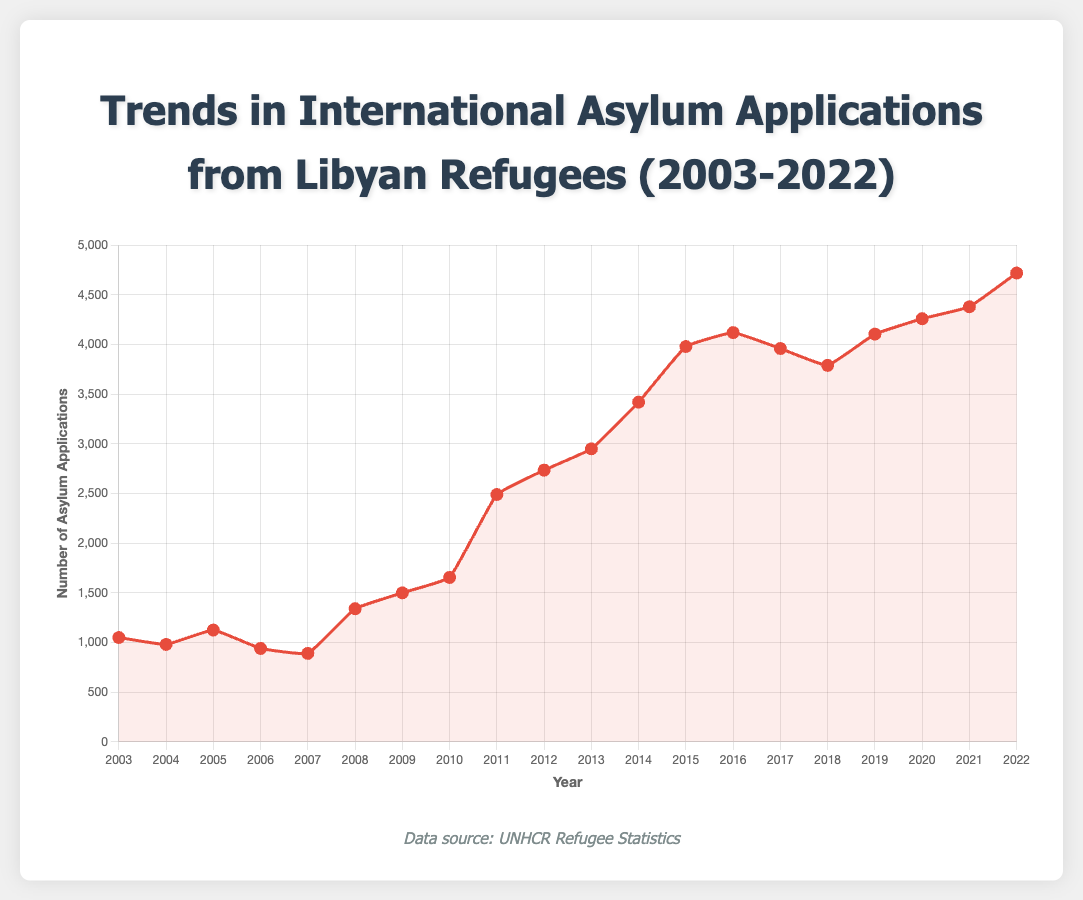What is the overall trend in the number of asylum applications from Libyan refugees over the past 20 years? Looking at the line plot, the number of asylum applications generally increased over the 20-year period from 2003 to 2022. There was a noticeable rise starting around 2008, with more significant increases during and after 2011, and a steady upward trend continuing through 2022.
Answer: An increasing trend Which year had the highest number of asylum applications? By examining the peak of the line plot, it is clear that 2022 had the highest number of asylum applications with a value of 4720.
Answer: 2022 How did the number of asylum applications change from 2010 to 2011? Comparing the points on the line plot representing 2010 and 2011, the number of asylum applications increased from 1655 in 2010 to 2490 in 2011. The difference is 2490 - 1655 = 835.
Answer: Increased by 835 What is the average number of asylum applications per year from 2003 to 2022? Calculating the average involves summing the total number of asylum applications over the years and dividing by the number of years. Summing up the applications: 1050 + 980 + 1125 + 940 + 890 + 1340 + 1500 + 1655 + 2490 + 2735 + 2950 + 3420 + 3980 + 4120 + 3960 + 3790 + 4105 + 4260 + 4380 + 4720 = 57470. Dividing by the number of years (20): 57470 / 20 = 2873.5.
Answer: 2873.5 Which year experienced the largest decrease in asylum applications compared to the previous year? By scanning the line plot for the most significant drop between consecutive years, the largest decrease occurred between 2005 and 2006, from 1125 to 940. The decrease is 1125 - 940 = 185.
Answer: 2006 What is the total number of asylum applications filed from 2015 to 2020? Summing the number of asylum applications for each year from 2015 to 2020: 3980 (2015) + 4120 (2016) + 3960 (2017) + 3790 (2018) + 4105 (2019) + 4260 (2020) = 24215.
Answer: 24215 How does the number of asylum applications in 2019 compare to the number in 2020? Comparing the points on the line plot for 2019 and 2020, the number of asylum applications increased from 4105 in 2019 to 4260 in 2020, which is an increase of 4260 - 4105 = 155.
Answer: Increased by 155 Which years show an increase in asylum applications for three consecutive years? Tracking the line plot, asylum applications increased consecutively from 2010 to 2013: from 1655 (2010) to 2490 (2011), 2735 (2012), and 2950 (2013), and another period from 2020 to 2022: from 4260 (2020) to 4380 (2021) and 4720 (2022).
Answer: 2010-2013, 2020-2022 How many years had over 4000 asylum applications? Identifying the years on the line plot where the asylum applications exceed 4000, they are 2016 (4120), 2019 (4105), 2020 (4260), 2021 (4380), and 2022 (4720). Hence, there are 5 years in total.
Answer: 5 years 